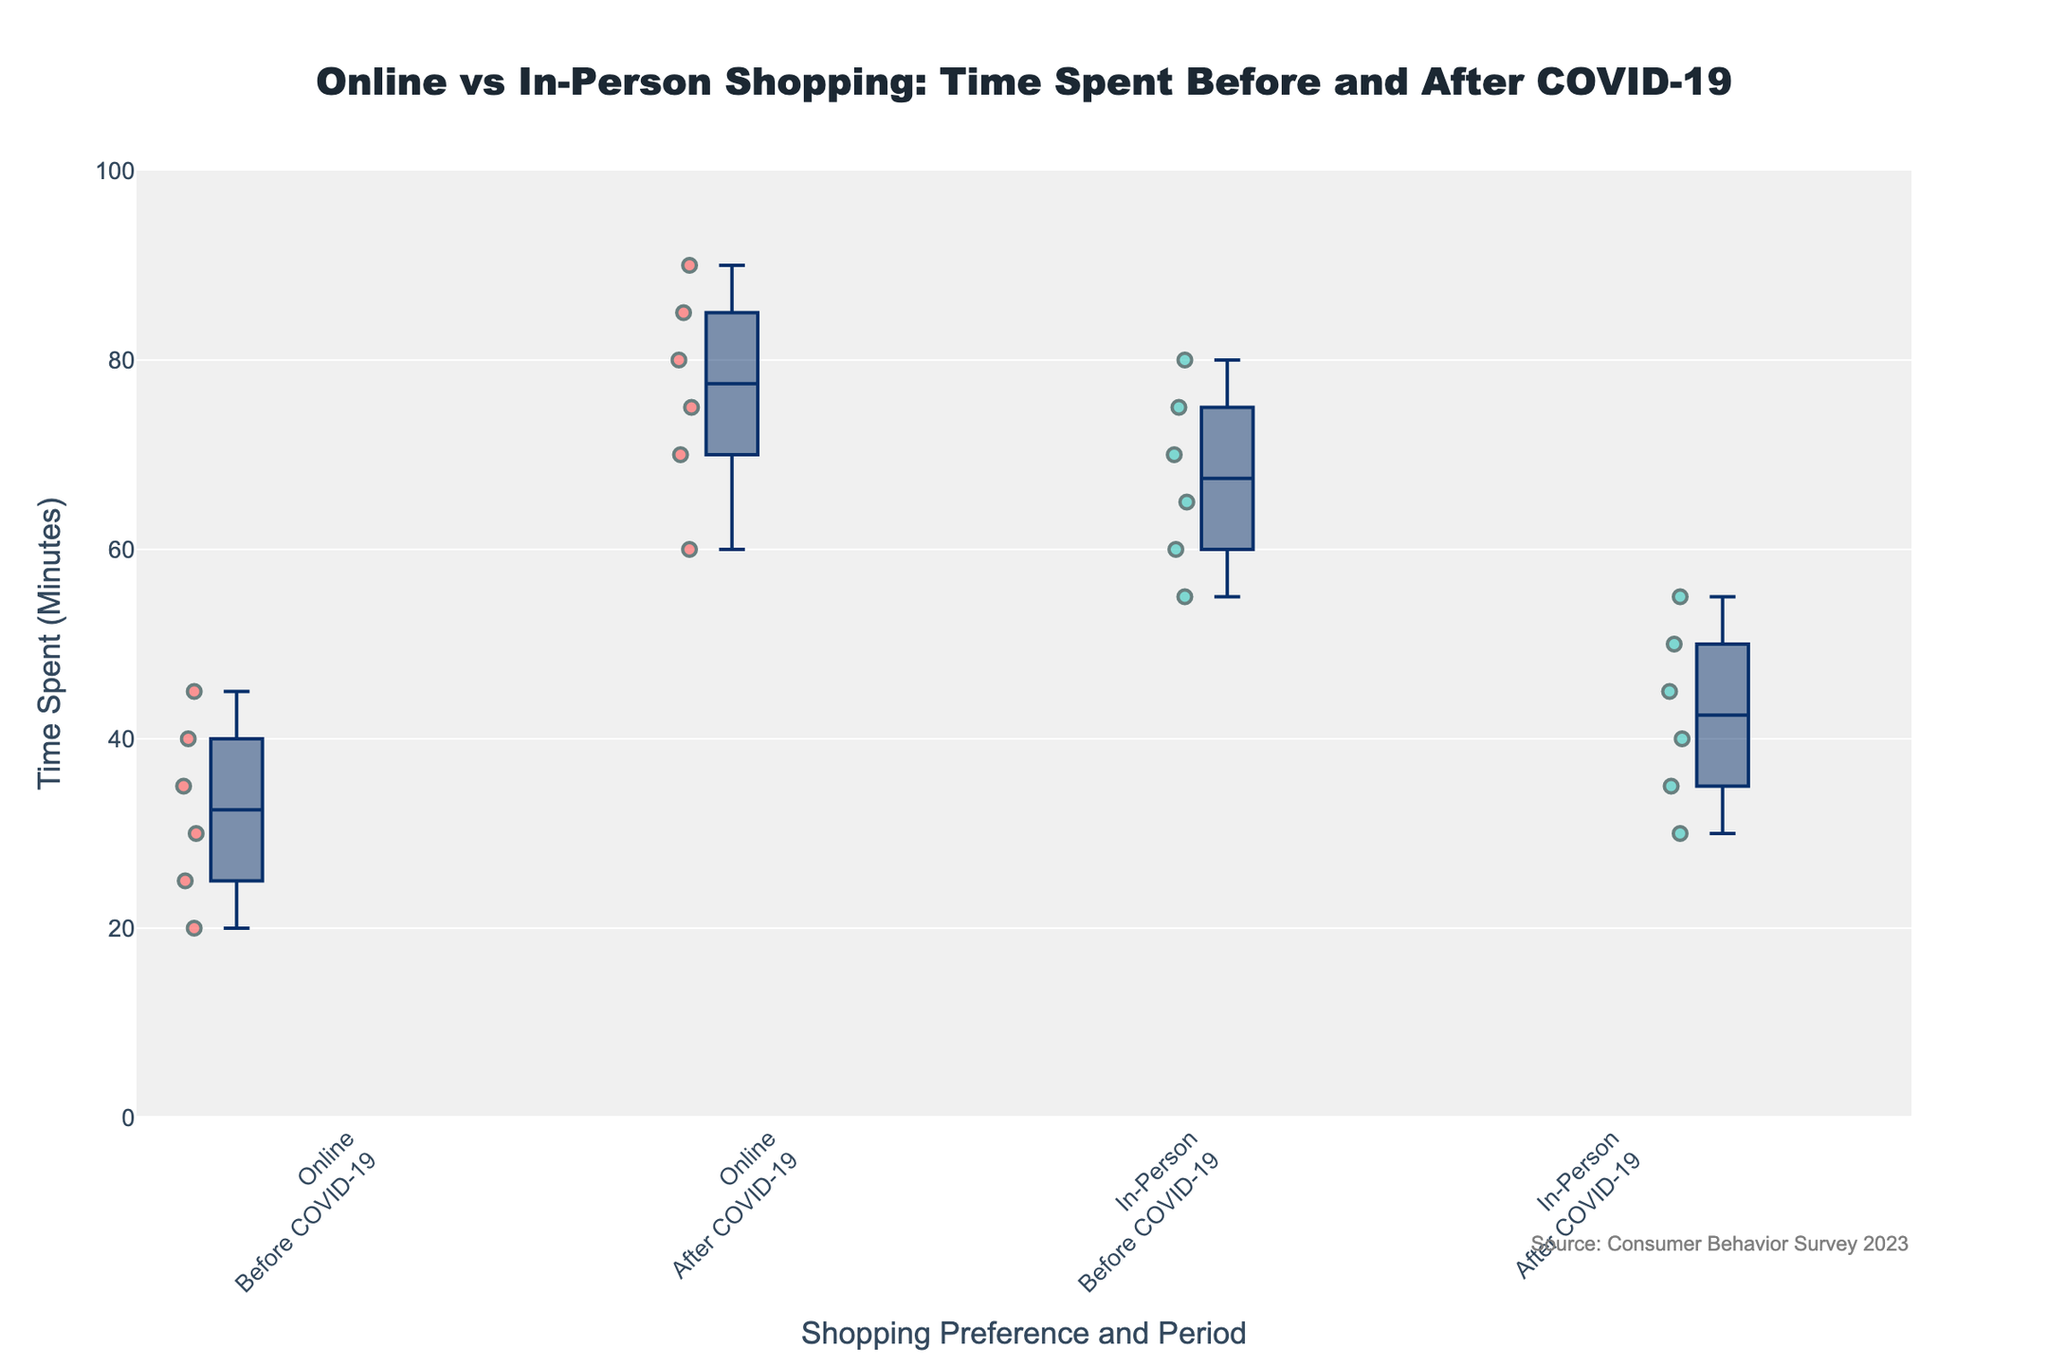How many unique shopping preferences are depicted in the figure? The figure shows box plots for different shopping preferences. By observing the labels on the x-axis, it is clear that there are two distinct shopping preferences: Online and In-Person.
Answer: 2 What is the title of the figure? The title of the figure is found at the top of the plot. It reads "Online vs In-Person Shopping: Time Spent Before and After COVID-19".
Answer: Online vs In-Person Shopping: Time Spent Before and After COVID-19 Which shopping preference shows a more significant increase in time spent from the period before COVID-19 to after COVID-19? By comparing the Online and In-Person box plots for both periods, it is evident that Online shopping shows a more significant increase in time spent. This is seen due to the noticeable rise in the median and data points in the Online section after COVID-19 compared to before.
Answer: Online What color represents the In-Person shopping preference in the figure? The In-Person shopping preference is represented by a teal color. This is consistent across both periods shown in the figure.
Answer: Teal What is the approximate median time spent on Online shopping after COVID-19? The median of a box plot is shown by the line inside the box. For Online shopping after COVID-19, the median appears to be around 80 minutes.
Answer: 80 minutes Compare the interquartile ranges of Time Spent before COVID-19 for both shopping preferences. Which one is larger? The interquartile range (IQR) is the distance between the first and third quartiles (Q1 and Q3). By observing the box plots, the IQR for In-Person shopping before COVID-19 is larger than that for Online shopping before COVID-19. This is indicated by the larger span of the box for In-Person shopping.
Answer: In-Person How does the max time spent on Online shopping after COVID-19 compare to the max time before COVID-19? The maximum time is indicated by the top whisker of the box plot. For Online shopping after COVID-19, the max time is higher compared to that before COVID-19. Before COVID-19, the max is around 45 minutes, and after COVID-19, it reaches approximately 90 minutes.
Answer: Higher Between Online and In-Person shopping after COVID-19, which has a lower minimum time spent, and what is that time? The minimum time spent is shown by the bottom whisker of the box plot. In the after COVID-19 period, the lowest time spent is observed in the In-Person category and it is about 30 minutes.
Answer: In-Person, 30 minutes What is the range of time spent on In-Person shopping before COVID-19? The range is calculated by subtracting the minimum value from the maximum value. The bottom whisker shows a minimum of 55 minutes and the top whisker shows a maximum of 80 minutes, so the range is 80 - 55 = 25 minutes.
Answer: 25 minutes Among the Consumer Groups shopping Online after COVID-19, which group shows the highest time spent and what is the value? The highest time spent is indicated by the topmost dot in the Online after COVID-19 group. The Busy Professionals group shows the highest time spent with approximately 90 minutes.
Answer: Busy Professionals, 90 minutes 